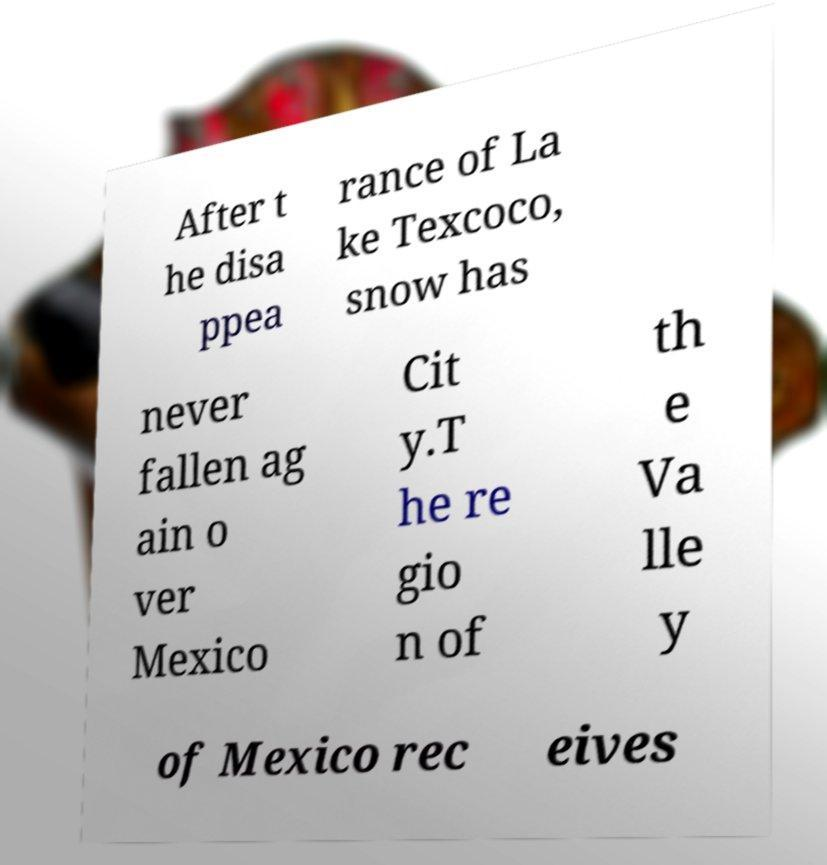For documentation purposes, I need the text within this image transcribed. Could you provide that? After t he disa ppea rance of La ke Texcoco, snow has never fallen ag ain o ver Mexico Cit y.T he re gio n of th e Va lle y of Mexico rec eives 